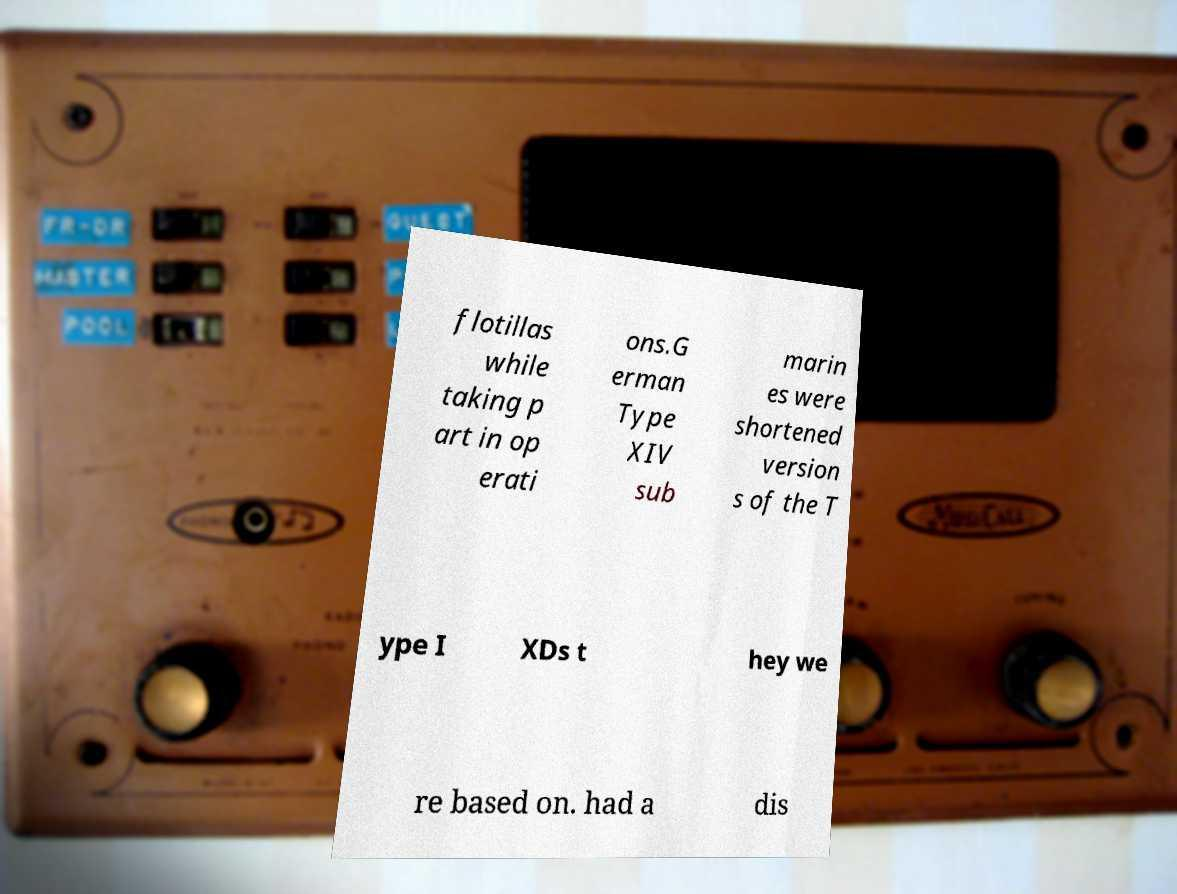For documentation purposes, I need the text within this image transcribed. Could you provide that? flotillas while taking p art in op erati ons.G erman Type XIV sub marin es were shortened version s of the T ype I XDs t hey we re based on. had a dis 